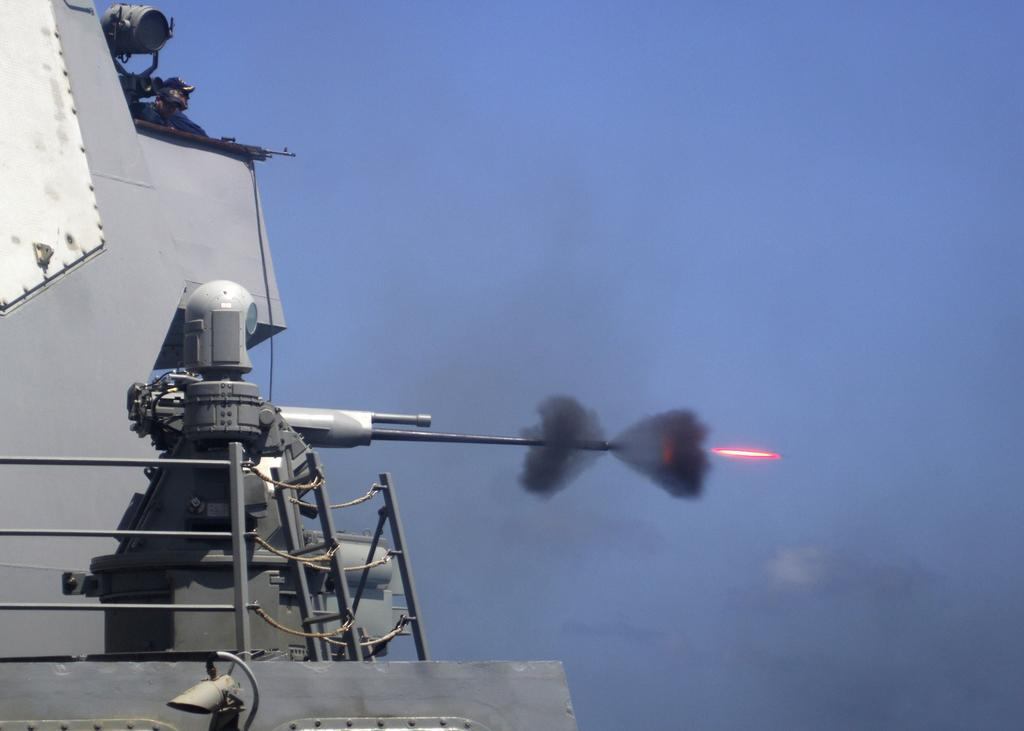What can be seen in the sky in the image? There is a ship in the sky in the image. What type of vehicle is in the sky? The vehicle in the sky is a ship. Who or what is present in the image besides the ship? There is a person, a CCTV camera, grills, and a missile in the image. What might be used for monitoring or surveillance in the image? A CCTV camera is present in the image for monitoring or surveillance. What is the purpose of the grills in the image? The purpose of the grills in the image is not specified, but they could be used for cooking or as a decorative element. What type of metal is used to construct the expansion in the image? There is no mention of an expansion in the image, and therefore no metal can be associated with it. 